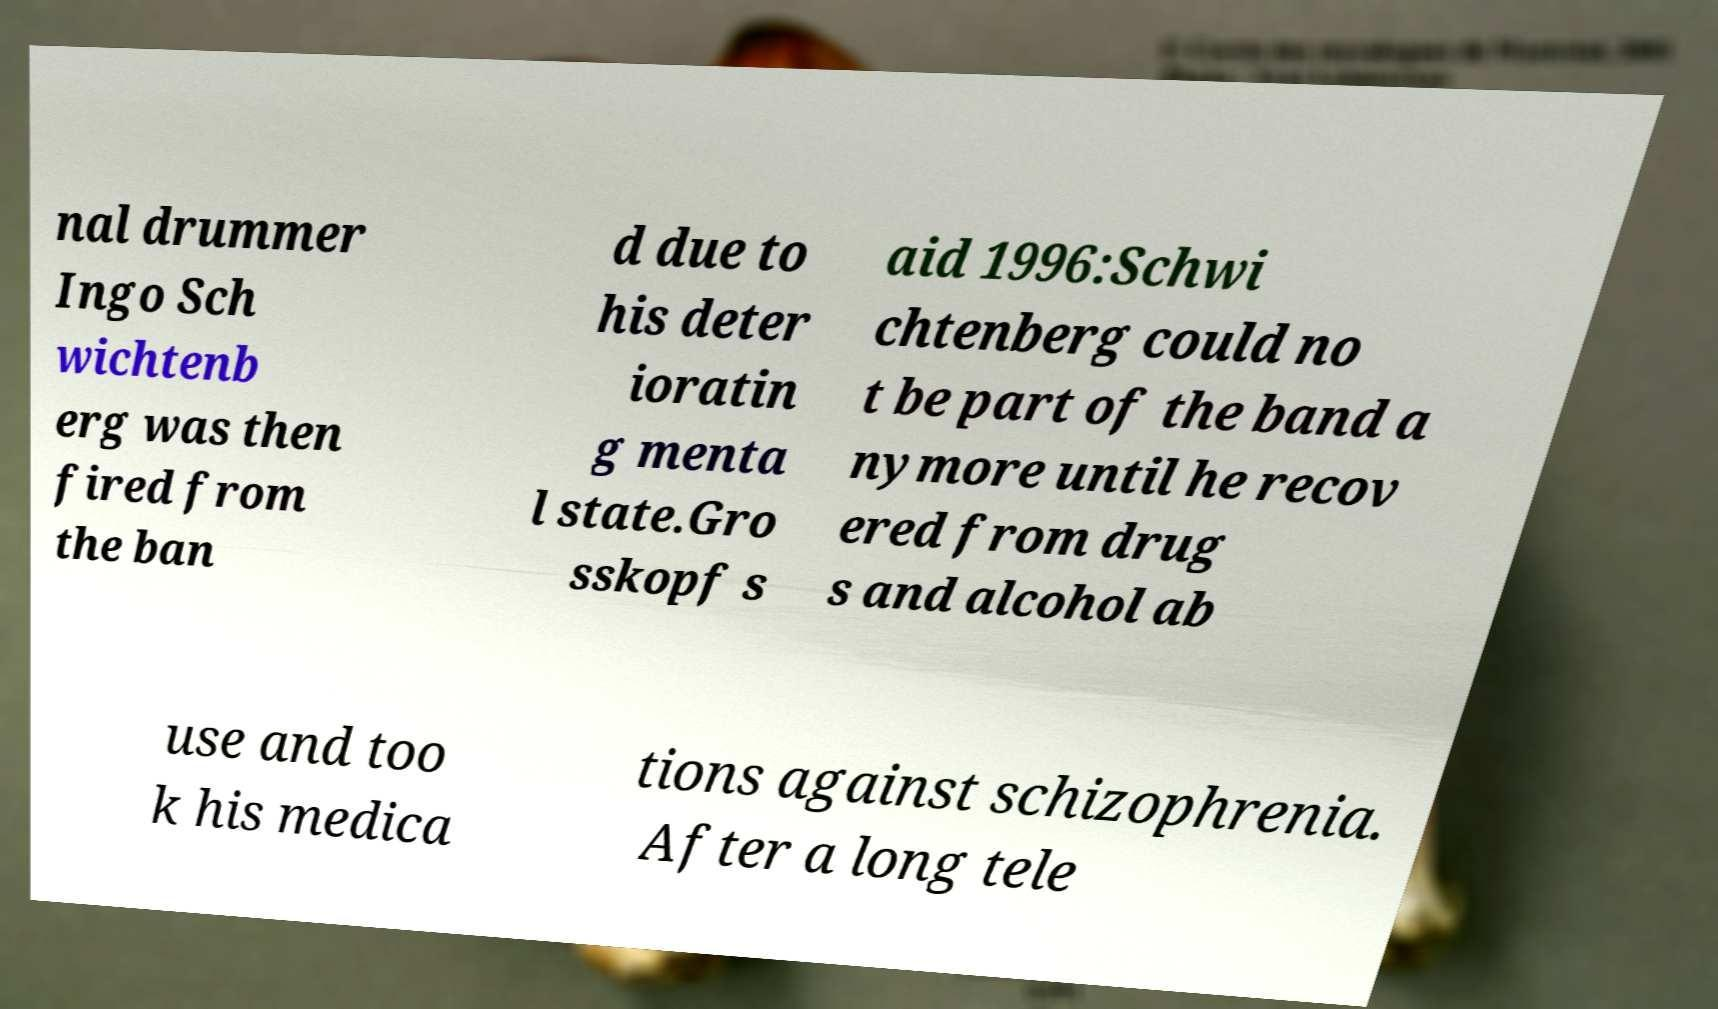Please identify and transcribe the text found in this image. nal drummer Ingo Sch wichtenb erg was then fired from the ban d due to his deter ioratin g menta l state.Gro sskopf s aid 1996:Schwi chtenberg could no t be part of the band a nymore until he recov ered from drug s and alcohol ab use and too k his medica tions against schizophrenia. After a long tele 